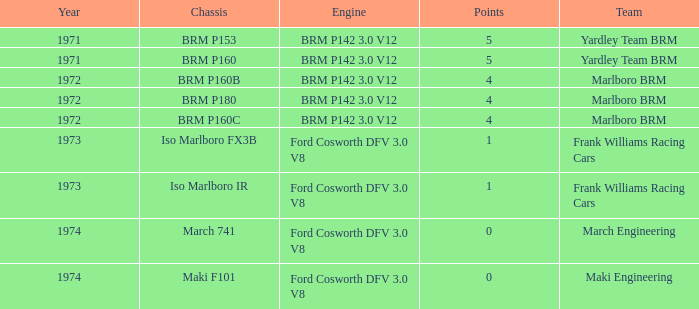What are the highest points for the team of marlboro brm with brm p180 as the chassis? 4.0. I'm looking to parse the entire table for insights. Could you assist me with that? {'header': ['Year', 'Chassis', 'Engine', 'Points', 'Team'], 'rows': [['1971', 'BRM P153', 'BRM P142 3.0 V12', '5', 'Yardley Team BRM'], ['1971', 'BRM P160', 'BRM P142 3.0 V12', '5', 'Yardley Team BRM'], ['1972', 'BRM P160B', 'BRM P142 3.0 V12', '4', 'Marlboro BRM'], ['1972', 'BRM P180', 'BRM P142 3.0 V12', '4', 'Marlboro BRM'], ['1972', 'BRM P160C', 'BRM P142 3.0 V12', '4', 'Marlboro BRM'], ['1973', 'Iso Marlboro FX3B', 'Ford Cosworth DFV 3.0 V8', '1', 'Frank Williams Racing Cars'], ['1973', 'Iso Marlboro IR', 'Ford Cosworth DFV 3.0 V8', '1', 'Frank Williams Racing Cars'], ['1974', 'March 741', 'Ford Cosworth DFV 3.0 V8', '0', 'March Engineering'], ['1974', 'Maki F101', 'Ford Cosworth DFV 3.0 V8', '0', 'Maki Engineering']]} 